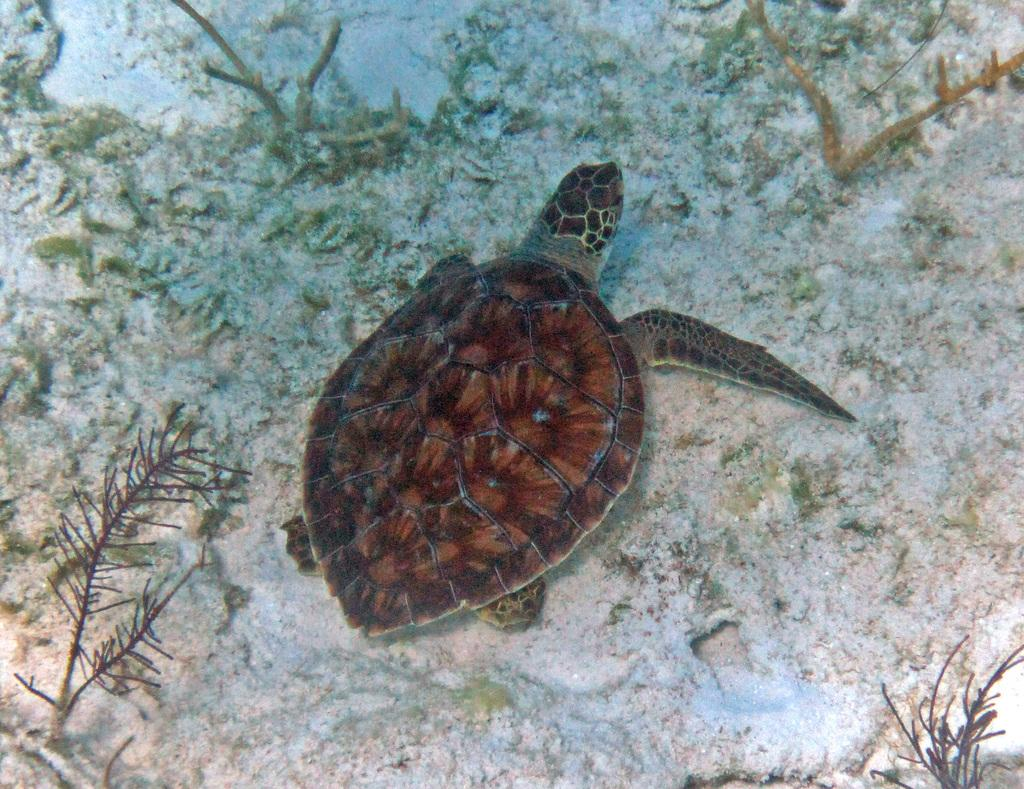What animal is present in the image? There is a tortoise in the image. Where is the tortoise located? The tortoise is in the water. What type of underwater environment can be seen in the image? There are reefs in the image. What type of cap is the tortoise wearing in the image? There is no cap present in the image; the tortoise is not wearing any clothing. 